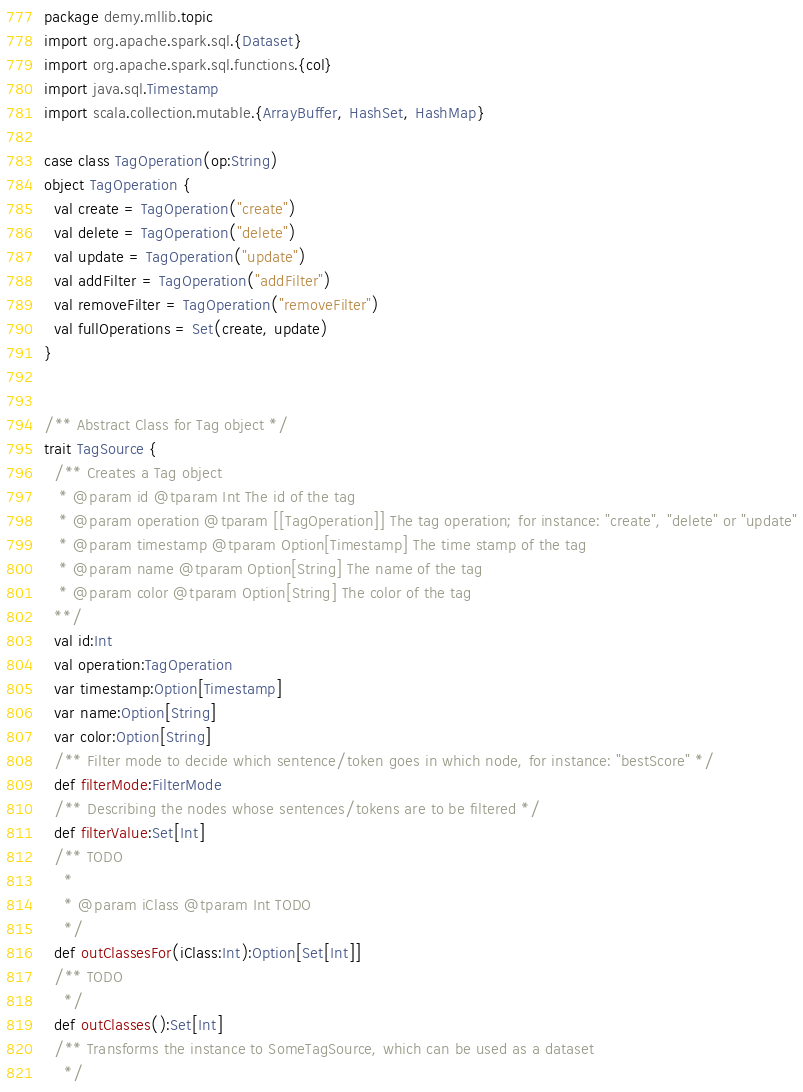<code> <loc_0><loc_0><loc_500><loc_500><_Scala_>package demy.mllib.topic
import org.apache.spark.sql.{Dataset}
import org.apache.spark.sql.functions.{col}
import java.sql.Timestamp
import scala.collection.mutable.{ArrayBuffer, HashSet, HashMap}

case class TagOperation(op:String)
object TagOperation {
  val create = TagOperation("create")
  val delete = TagOperation("delete")
  val update = TagOperation("update")
  val addFilter = TagOperation("addFilter")
  val removeFilter = TagOperation("removeFilter")
  val fullOperations = Set(create, update)
}


/** Abstract Class for Tag object */
trait TagSource {
  /** Creates a Tag object
   * @param id @tparam Int The id of the tag
   * @param operation @tparam [[TagOperation]] The tag operation; for instance: "create", "delete" or "update"
   * @param timestamp @tparam Option[Timestamp] The time stamp of the tag
   * @param name @tparam Option[String] The name of the tag
   * @param color @tparam Option[String] The color of the tag
  **/
  val id:Int
  val operation:TagOperation
  var timestamp:Option[Timestamp]
  var name:Option[String]
  var color:Option[String]
  /** Filter mode to decide which sentence/token goes in which node, for instance: "bestScore" */
  def filterMode:FilterMode
  /** Describing the nodes whose sentences/tokens are to be filtered */
  def filterValue:Set[Int]
  /** TODO
    *
    * @param iClass @tparam Int TODO
    */
  def outClassesFor(iClass:Int):Option[Set[Int]]
  /** TODO
    */
  def outClasses():Set[Int]
  /** Transforms the instance to SomeTagSource, which can be used as a dataset
    */</code> 